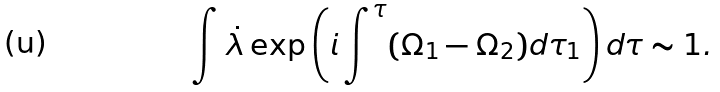<formula> <loc_0><loc_0><loc_500><loc_500>\int \dot { \lambda } \exp \left ( { i \int ^ { \tau } ( \Omega _ { 1 } - \Omega _ { 2 } ) d \tau _ { 1 } } \right ) d \tau \sim 1 .</formula> 